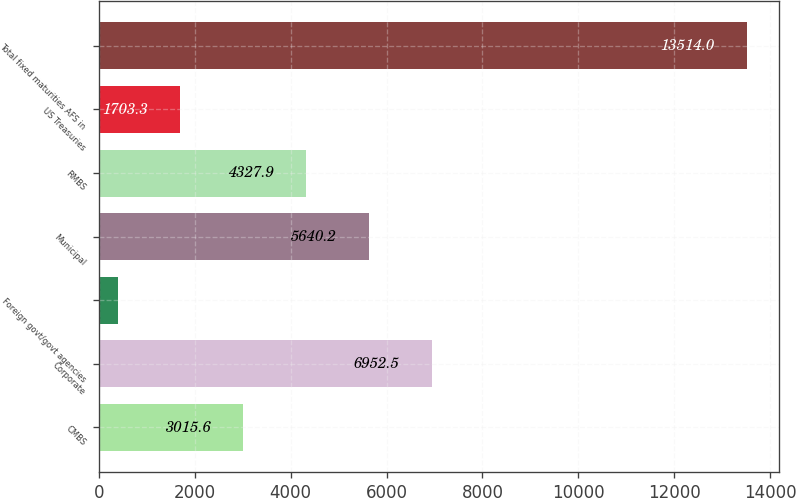Convert chart to OTSL. <chart><loc_0><loc_0><loc_500><loc_500><bar_chart><fcel>CMBS<fcel>Corporate<fcel>Foreign govt/govt agencies<fcel>Municipal<fcel>RMBS<fcel>US Treasuries<fcel>Total fixed maturities AFS in<nl><fcel>3015.6<fcel>6952.5<fcel>391<fcel>5640.2<fcel>4327.9<fcel>1703.3<fcel>13514<nl></chart> 